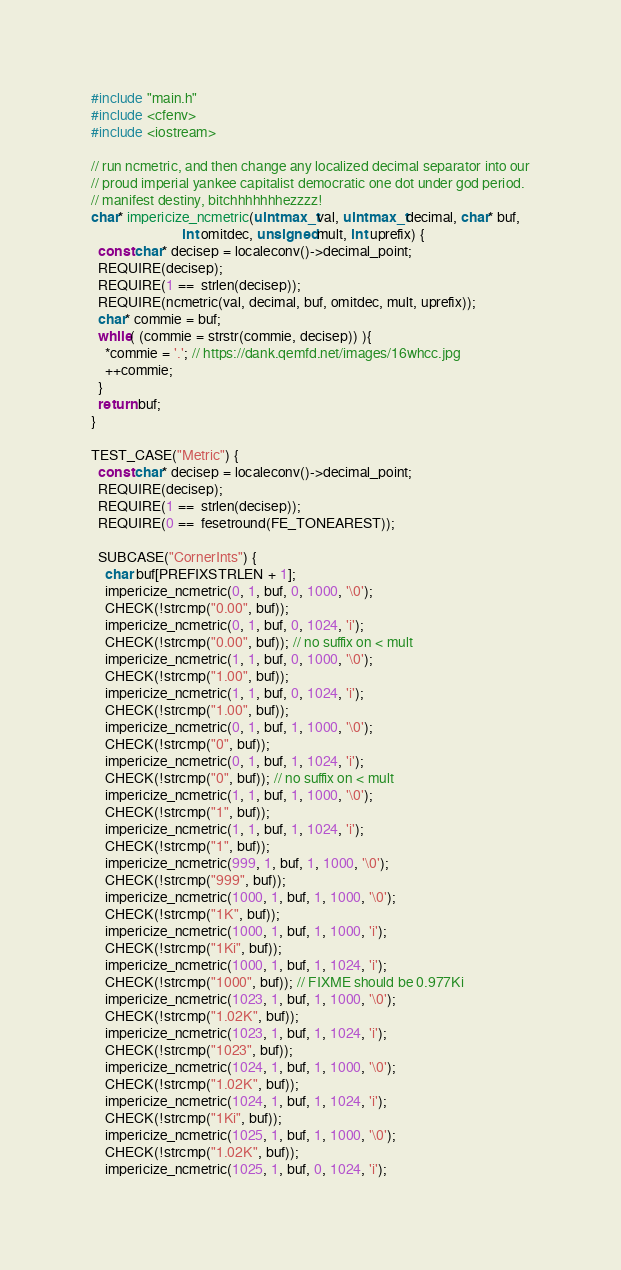<code> <loc_0><loc_0><loc_500><loc_500><_C++_>#include "main.h"
#include <cfenv>
#include <iostream>

// run ncmetric, and then change any localized decimal separator into our
// proud imperial yankee capitalist democratic one dot under god period.
// manifest destiny, bitchhhhhhhezzzz!
char* impericize_ncmetric(uintmax_t val, uintmax_t decimal, char* buf,
                          int omitdec, unsigned mult, int uprefix) {
  const char* decisep = localeconv()->decimal_point;
  REQUIRE(decisep);
  REQUIRE(1 ==  strlen(decisep));
  REQUIRE(ncmetric(val, decimal, buf, omitdec, mult, uprefix));
  char* commie = buf;
  while( (commie = strstr(commie, decisep)) ){
    *commie = '.'; // https://dank.qemfd.net/images/16whcc.jpg
    ++commie;
  }
  return buf;
}

TEST_CASE("Metric") {
  const char* decisep = localeconv()->decimal_point;
  REQUIRE(decisep);
  REQUIRE(1 ==  strlen(decisep));
  REQUIRE(0 ==  fesetround(FE_TONEAREST));

  SUBCASE("CornerInts") {
    char buf[PREFIXSTRLEN + 1];
    impericize_ncmetric(0, 1, buf, 0, 1000, '\0');
    CHECK(!strcmp("0.00", buf));
    impericize_ncmetric(0, 1, buf, 0, 1024, 'i');
    CHECK(!strcmp("0.00", buf)); // no suffix on < mult
    impericize_ncmetric(1, 1, buf, 0, 1000, '\0');
    CHECK(!strcmp("1.00", buf));
    impericize_ncmetric(1, 1, buf, 0, 1024, 'i');
    CHECK(!strcmp("1.00", buf));
    impericize_ncmetric(0, 1, buf, 1, 1000, '\0');
    CHECK(!strcmp("0", buf));
    impericize_ncmetric(0, 1, buf, 1, 1024, 'i');
    CHECK(!strcmp("0", buf)); // no suffix on < mult
    impericize_ncmetric(1, 1, buf, 1, 1000, '\0');
    CHECK(!strcmp("1", buf));
    impericize_ncmetric(1, 1, buf, 1, 1024, 'i');
    CHECK(!strcmp("1", buf));
    impericize_ncmetric(999, 1, buf, 1, 1000, '\0');
    CHECK(!strcmp("999", buf));
    impericize_ncmetric(1000, 1, buf, 1, 1000, '\0');
    CHECK(!strcmp("1K", buf));
    impericize_ncmetric(1000, 1, buf, 1, 1000, 'i');
    CHECK(!strcmp("1Ki", buf));
    impericize_ncmetric(1000, 1, buf, 1, 1024, 'i');
    CHECK(!strcmp("1000", buf)); // FIXME should be 0.977Ki
    impericize_ncmetric(1023, 1, buf, 1, 1000, '\0');
    CHECK(!strcmp("1.02K", buf));
    impericize_ncmetric(1023, 1, buf, 1, 1024, 'i');
    CHECK(!strcmp("1023", buf));
    impericize_ncmetric(1024, 1, buf, 1, 1000, '\0');
    CHECK(!strcmp("1.02K", buf));
    impericize_ncmetric(1024, 1, buf, 1, 1024, 'i');
    CHECK(!strcmp("1Ki", buf));
    impericize_ncmetric(1025, 1, buf, 1, 1000, '\0');
    CHECK(!strcmp("1.02K", buf));
    impericize_ncmetric(1025, 1, buf, 0, 1024, 'i');</code> 